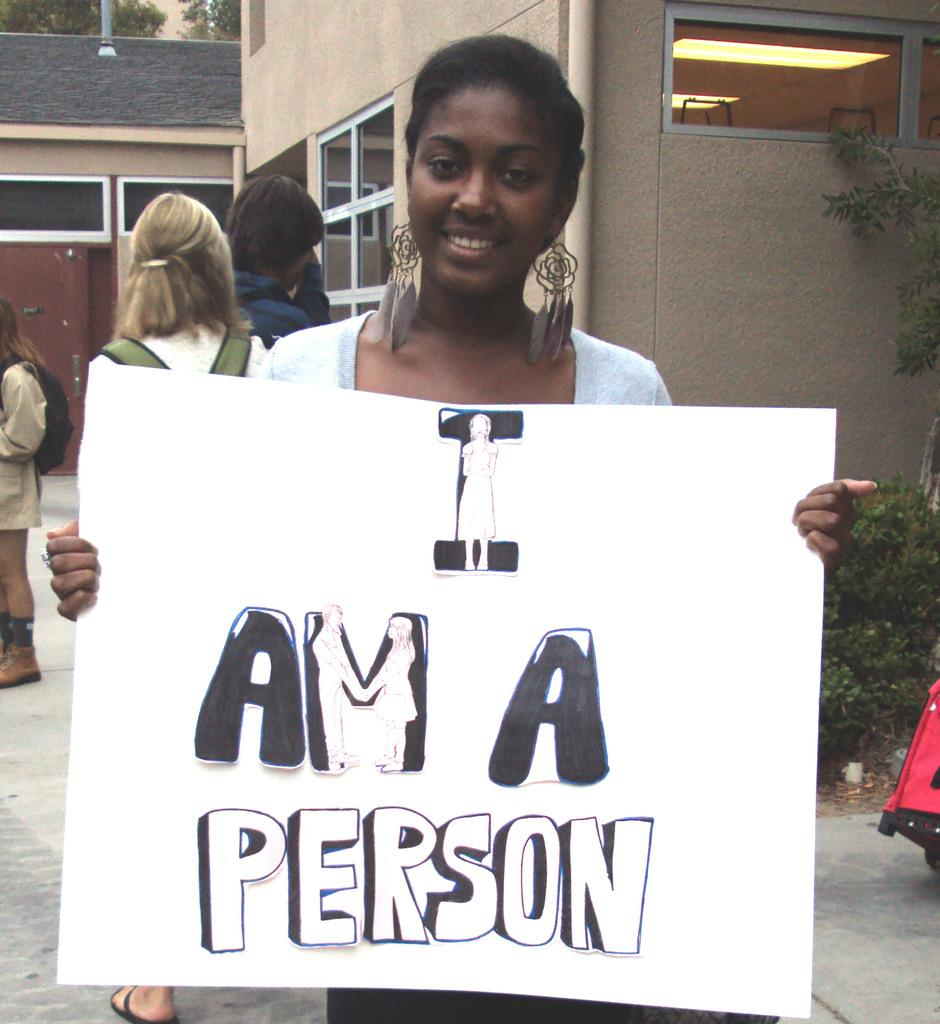What is the woman in the image doing? The woman is standing and smiling in the image. What is the woman holding in the image? The woman is holding a board in the image. How many people are present in the image? There are three persons standing in the image. What can be seen in the background of the image? There is a building and trees in the background of the image. What type of beef is being ordered by the woman in the image? There is no beef or order mentioned in the image; the woman is holding a board and standing with two other people. What color is the ink used to write on the board in the image? There is no indication of writing or ink on the board in the image; it is simply being held by the woman. 